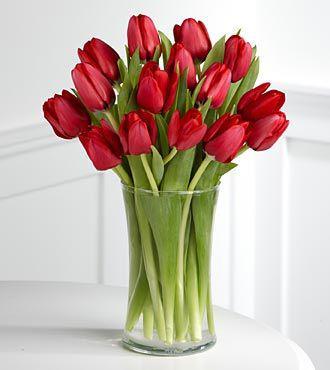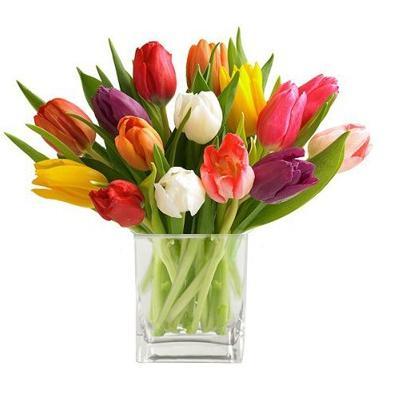The first image is the image on the left, the second image is the image on the right. Given the left and right images, does the statement "Each of two vases of multicolored tulips is clear so that the green flower stems are visible, and contains at least three yellow flowers." hold true? Answer yes or no. No. The first image is the image on the left, the second image is the image on the right. Analyze the images presented: Is the assertion "Each image features multicolor tulips in a clear glass vase, and one of the vases has a rather spherical shape." valid? Answer yes or no. No. 